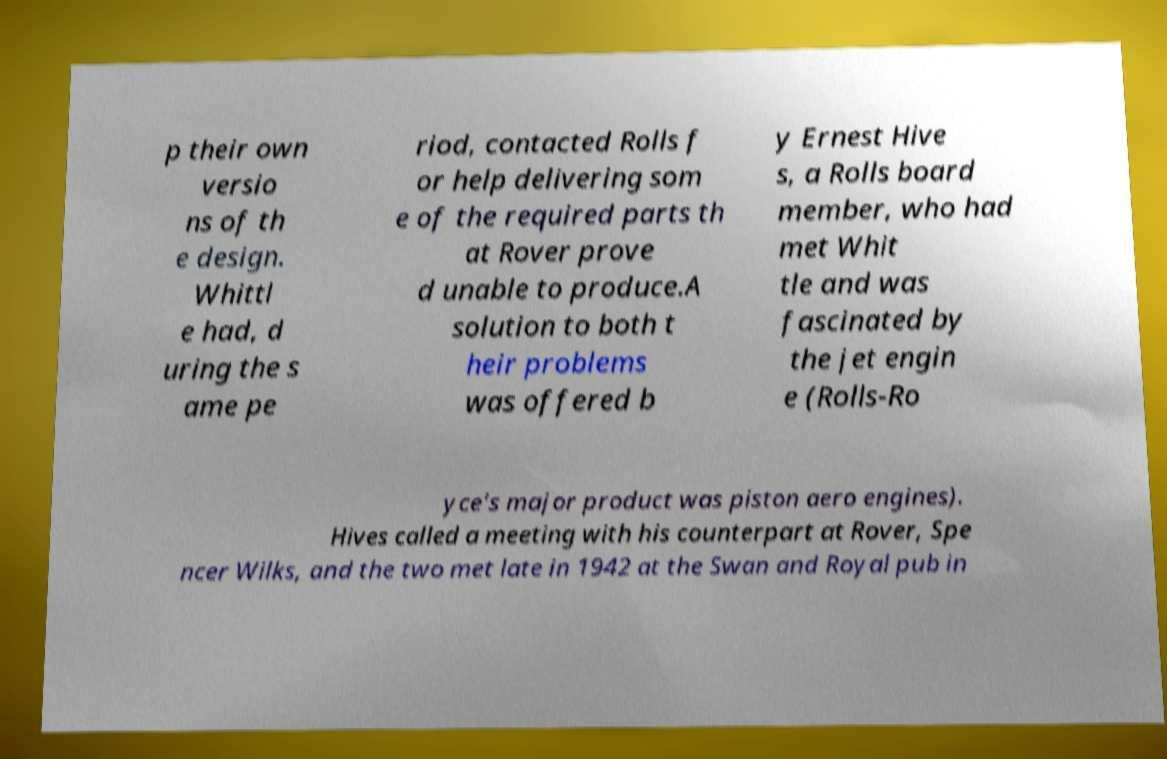There's text embedded in this image that I need extracted. Can you transcribe it verbatim? p their own versio ns of th e design. Whittl e had, d uring the s ame pe riod, contacted Rolls f or help delivering som e of the required parts th at Rover prove d unable to produce.A solution to both t heir problems was offered b y Ernest Hive s, a Rolls board member, who had met Whit tle and was fascinated by the jet engin e (Rolls-Ro yce's major product was piston aero engines). Hives called a meeting with his counterpart at Rover, Spe ncer Wilks, and the two met late in 1942 at the Swan and Royal pub in 